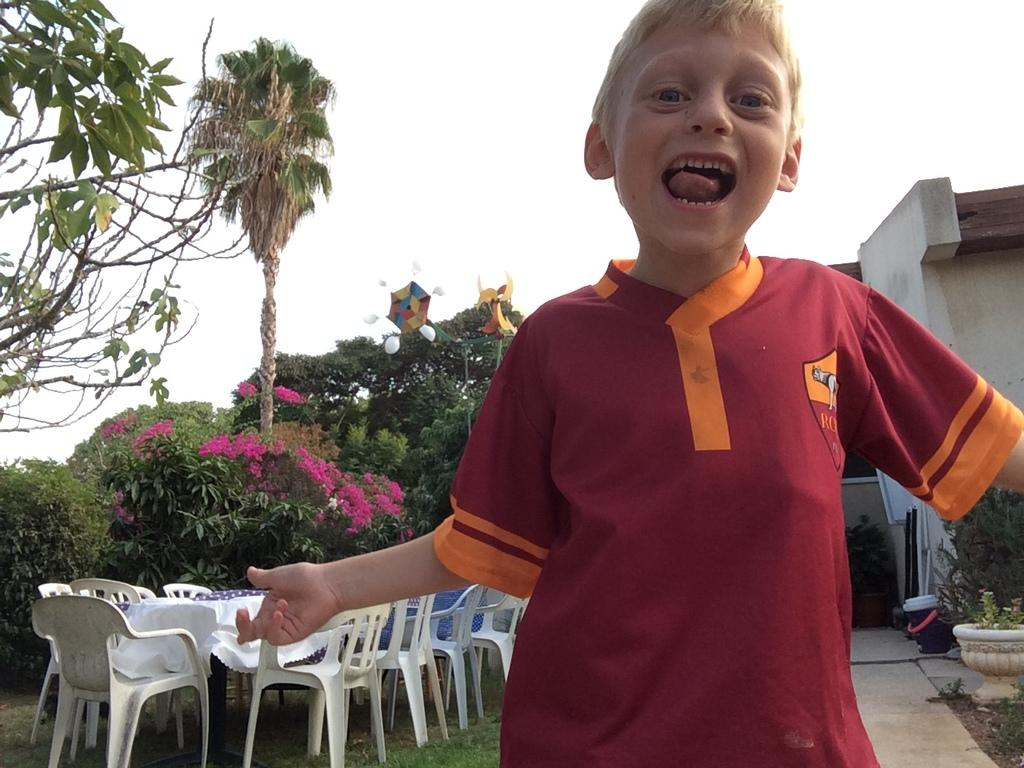What is the main subject of the image? There is a boy standing in the image. What can be seen in the background of the image? There are chairs, plants, the sky, and a building visible in the background of the image. What type of shock can be seen affecting the grandfather in the image? There is no grandfather or shock present in the image. What angle is the boy standing at in the image? The angle at which the boy is standing cannot be determined from the image alone, as it does not provide a reference point for measuring angles. 